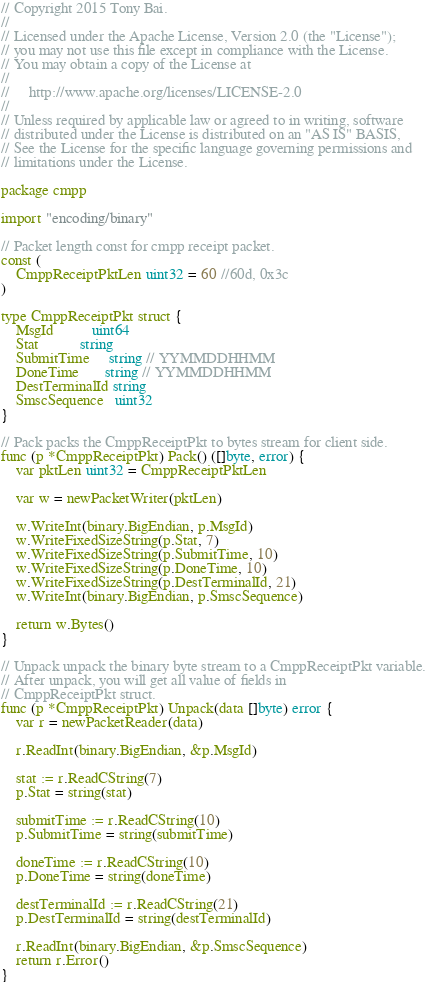<code> <loc_0><loc_0><loc_500><loc_500><_Go_>// Copyright 2015 Tony Bai.
//
// Licensed under the Apache License, Version 2.0 (the "License");
// you may not use this file except in compliance with the License.
// You may obtain a copy of the License at
//
//     http://www.apache.org/licenses/LICENSE-2.0
//
// Unless required by applicable law or agreed to in writing, software
// distributed under the License is distributed on an "AS IS" BASIS,
// See the License for the specific language governing permissions and
// limitations under the License.

package cmpp

import "encoding/binary"

// Packet length const for cmpp receipt packet.
const (
	CmppReceiptPktLen uint32 = 60 //60d, 0x3c
)

type CmppReceiptPkt struct {
	MsgId          uint64
	Stat           string
	SubmitTime     string // YYMMDDHHMM
	DoneTime       string // YYMMDDHHMM
	DestTerminalId string
	SmscSequence   uint32
}

// Pack packs the CmppReceiptPkt to bytes stream for client side.
func (p *CmppReceiptPkt) Pack() ([]byte, error) {
	var pktLen uint32 = CmppReceiptPktLen

	var w = newPacketWriter(pktLen)

	w.WriteInt(binary.BigEndian, p.MsgId)
	w.WriteFixedSizeString(p.Stat, 7)
	w.WriteFixedSizeString(p.SubmitTime, 10)
	w.WriteFixedSizeString(p.DoneTime, 10)
	w.WriteFixedSizeString(p.DestTerminalId, 21)
	w.WriteInt(binary.BigEndian, p.SmscSequence)

	return w.Bytes()
}

// Unpack unpack the binary byte stream to a CmppReceiptPkt variable.
// After unpack, you will get all value of fields in
// CmppReceiptPkt struct.
func (p *CmppReceiptPkt) Unpack(data []byte) error {
	var r = newPacketReader(data)

	r.ReadInt(binary.BigEndian, &p.MsgId)

	stat := r.ReadCString(7)
	p.Stat = string(stat)

	submitTime := r.ReadCString(10)
	p.SubmitTime = string(submitTime)

	doneTime := r.ReadCString(10)
	p.DoneTime = string(doneTime)

	destTerminalId := r.ReadCString(21)
	p.DestTerminalId = string(destTerminalId)

	r.ReadInt(binary.BigEndian, &p.SmscSequence)
	return r.Error()
}
</code> 